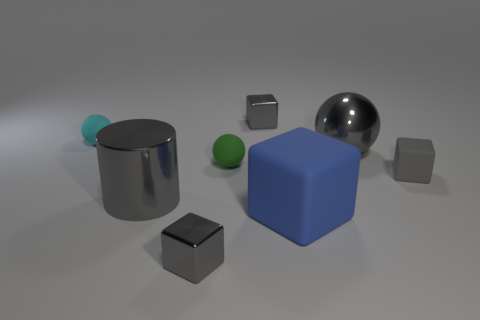Is the color of the small object in front of the gray matte block the same as the metallic cylinder?
Offer a very short reply. Yes. What number of objects are gray shiny things in front of the gray cylinder or big cyan spheres?
Give a very brief answer. 1. Are there more gray things right of the cyan matte ball than green balls that are in front of the big rubber object?
Your answer should be very brief. Yes. Are the small green sphere and the gray cylinder made of the same material?
Provide a short and direct response. No. There is a tiny object that is both behind the tiny green ball and to the right of the cyan thing; what is its shape?
Your answer should be compact. Cube. What is the shape of the big blue thing that is the same material as the cyan object?
Your response must be concise. Cube. Are there any big blue matte blocks?
Provide a succinct answer. Yes. There is a small metal object in front of the gray metallic ball; is there a object behind it?
Your answer should be very brief. Yes. There is another small thing that is the same shape as the cyan thing; what is it made of?
Your answer should be very brief. Rubber. Is the number of tiny gray shiny objects greater than the number of large objects?
Make the answer very short. No. 